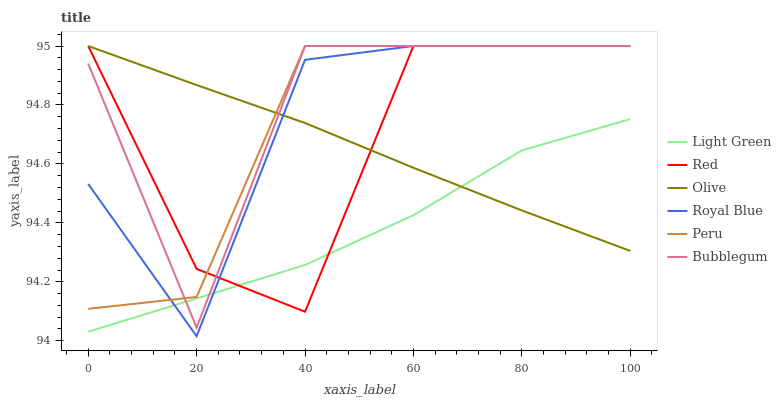Does Light Green have the minimum area under the curve?
Answer yes or no. Yes. Does Bubblegum have the maximum area under the curve?
Answer yes or no. Yes. Does Royal Blue have the minimum area under the curve?
Answer yes or no. No. Does Royal Blue have the maximum area under the curve?
Answer yes or no. No. Is Olive the smoothest?
Answer yes or no. Yes. Is Bubblegum the roughest?
Answer yes or no. Yes. Is Royal Blue the smoothest?
Answer yes or no. No. Is Royal Blue the roughest?
Answer yes or no. No. Does Royal Blue have the lowest value?
Answer yes or no. Yes. Does Bubblegum have the lowest value?
Answer yes or no. No. Does Red have the highest value?
Answer yes or no. Yes. Is Light Green less than Peru?
Answer yes or no. Yes. Is Peru greater than Light Green?
Answer yes or no. Yes. Does Red intersect Olive?
Answer yes or no. Yes. Is Red less than Olive?
Answer yes or no. No. Is Red greater than Olive?
Answer yes or no. No. Does Light Green intersect Peru?
Answer yes or no. No. 